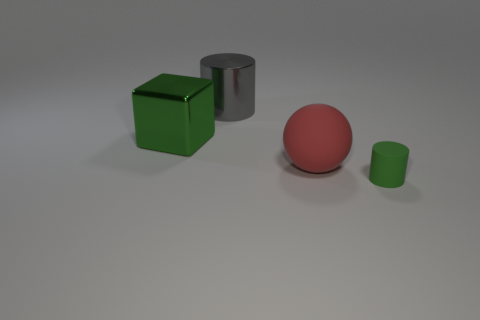Add 2 small red matte objects. How many objects exist? 6 Subtract all green cylinders. How many cylinders are left? 1 Subtract all cubes. How many objects are left? 3 Subtract 1 balls. How many balls are left? 0 Subtract all gray cylinders. How many yellow balls are left? 0 Subtract 0 brown cylinders. How many objects are left? 4 Subtract all purple cubes. Subtract all yellow balls. How many cubes are left? 1 Subtract all large red spheres. Subtract all brown metal cylinders. How many objects are left? 3 Add 1 cylinders. How many cylinders are left? 3 Add 1 gray matte balls. How many gray matte balls exist? 1 